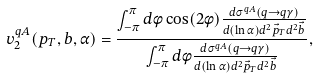Convert formula to latex. <formula><loc_0><loc_0><loc_500><loc_500>v _ { 2 } ^ { q A } ( p _ { T } , b , \alpha ) = \frac { \int _ { - \pi } ^ { \pi } d \phi \cos ( 2 \phi ) \frac { d \sigma ^ { q A } ( q \to q \gamma ) } { d ( \ln \alpha ) d ^ { 2 } \vec { p } _ { T } d ^ { 2 } \vec { b } } } { \int _ { - \pi } ^ { \pi } d \phi \frac { d \sigma ^ { q A } ( q \to q \gamma ) } { d ( \ln \alpha ) d ^ { 2 } \vec { p } _ { T } d ^ { 2 } \vec { b } } } ,</formula> 